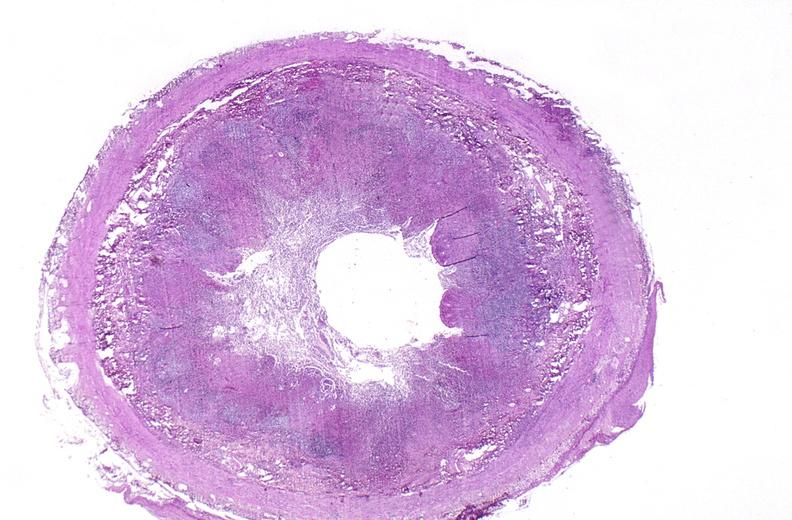where is this from?
Answer the question using a single word or phrase. Gastrointestinal system 